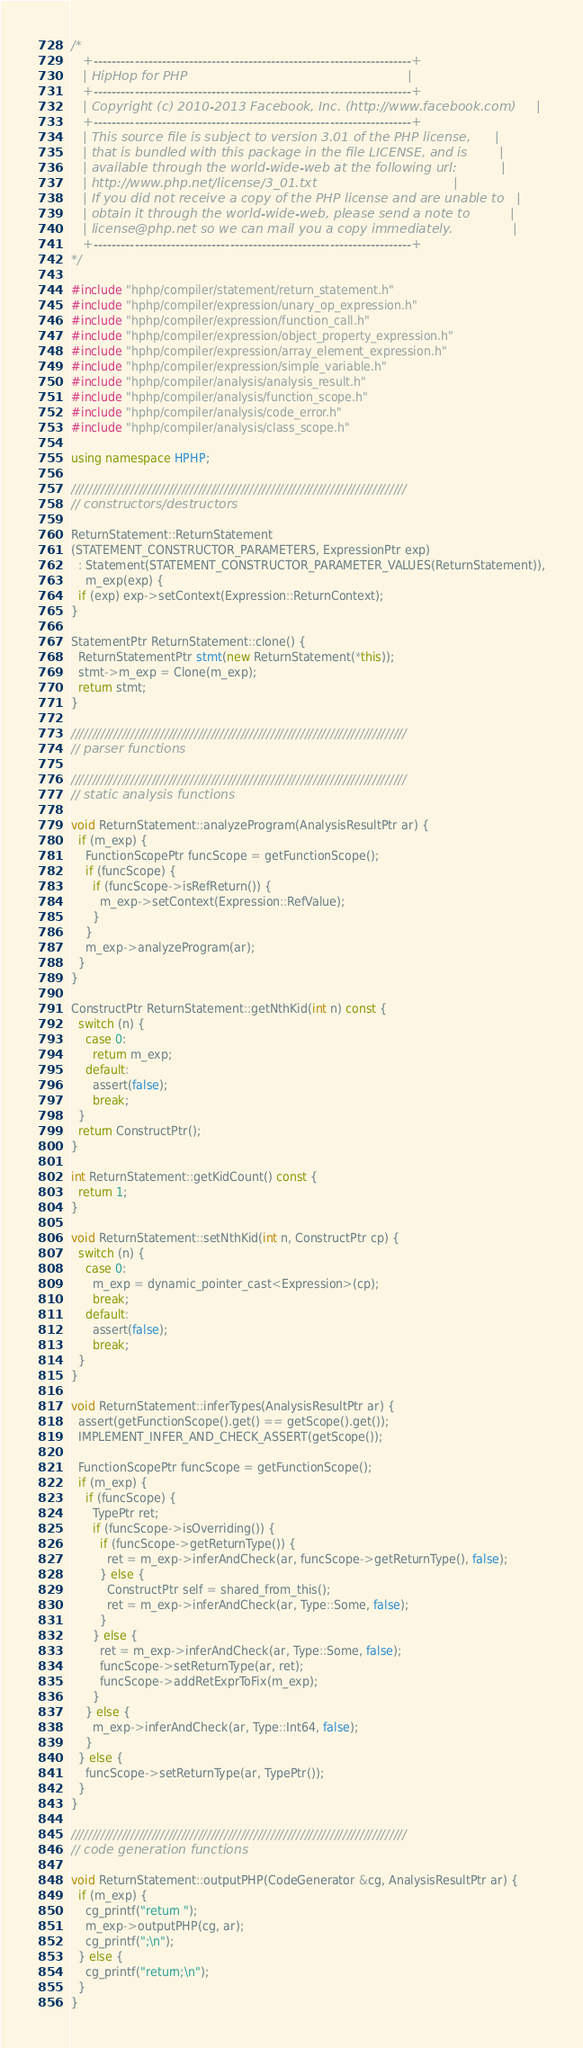<code> <loc_0><loc_0><loc_500><loc_500><_C++_>/*
   +----------------------------------------------------------------------+
   | HipHop for PHP                                                       |
   +----------------------------------------------------------------------+
   | Copyright (c) 2010-2013 Facebook, Inc. (http://www.facebook.com)     |
   +----------------------------------------------------------------------+
   | This source file is subject to version 3.01 of the PHP license,      |
   | that is bundled with this package in the file LICENSE, and is        |
   | available through the world-wide-web at the following url:           |
   | http://www.php.net/license/3_01.txt                                  |
   | If you did not receive a copy of the PHP license and are unable to   |
   | obtain it through the world-wide-web, please send a note to          |
   | license@php.net so we can mail you a copy immediately.               |
   +----------------------------------------------------------------------+
*/

#include "hphp/compiler/statement/return_statement.h"
#include "hphp/compiler/expression/unary_op_expression.h"
#include "hphp/compiler/expression/function_call.h"
#include "hphp/compiler/expression/object_property_expression.h"
#include "hphp/compiler/expression/array_element_expression.h"
#include "hphp/compiler/expression/simple_variable.h"
#include "hphp/compiler/analysis/analysis_result.h"
#include "hphp/compiler/analysis/function_scope.h"
#include "hphp/compiler/analysis/code_error.h"
#include "hphp/compiler/analysis/class_scope.h"

using namespace HPHP;

///////////////////////////////////////////////////////////////////////////////
// constructors/destructors

ReturnStatement::ReturnStatement
(STATEMENT_CONSTRUCTOR_PARAMETERS, ExpressionPtr exp)
  : Statement(STATEMENT_CONSTRUCTOR_PARAMETER_VALUES(ReturnStatement)),
    m_exp(exp) {
  if (exp) exp->setContext(Expression::ReturnContext);
}

StatementPtr ReturnStatement::clone() {
  ReturnStatementPtr stmt(new ReturnStatement(*this));
  stmt->m_exp = Clone(m_exp);
  return stmt;
}

///////////////////////////////////////////////////////////////////////////////
// parser functions

///////////////////////////////////////////////////////////////////////////////
// static analysis functions

void ReturnStatement::analyzeProgram(AnalysisResultPtr ar) {
  if (m_exp) {
    FunctionScopePtr funcScope = getFunctionScope();
    if (funcScope) {
      if (funcScope->isRefReturn()) {
        m_exp->setContext(Expression::RefValue);
      }
    }
    m_exp->analyzeProgram(ar);
  }
}

ConstructPtr ReturnStatement::getNthKid(int n) const {
  switch (n) {
    case 0:
      return m_exp;
    default:
      assert(false);
      break;
  }
  return ConstructPtr();
}

int ReturnStatement::getKidCount() const {
  return 1;
}

void ReturnStatement::setNthKid(int n, ConstructPtr cp) {
  switch (n) {
    case 0:
      m_exp = dynamic_pointer_cast<Expression>(cp);
      break;
    default:
      assert(false);
      break;
  }
}

void ReturnStatement::inferTypes(AnalysisResultPtr ar) {
  assert(getFunctionScope().get() == getScope().get());
  IMPLEMENT_INFER_AND_CHECK_ASSERT(getScope());

  FunctionScopePtr funcScope = getFunctionScope();
  if (m_exp) {
    if (funcScope) {
      TypePtr ret;
      if (funcScope->isOverriding()) {
        if (funcScope->getReturnType()) {
          ret = m_exp->inferAndCheck(ar, funcScope->getReturnType(), false);
        } else {
          ConstructPtr self = shared_from_this();
          ret = m_exp->inferAndCheck(ar, Type::Some, false);
        }
      } else {
        ret = m_exp->inferAndCheck(ar, Type::Some, false);
        funcScope->setReturnType(ar, ret);
        funcScope->addRetExprToFix(m_exp);
      }
    } else {
      m_exp->inferAndCheck(ar, Type::Int64, false);
    }
  } else {
    funcScope->setReturnType(ar, TypePtr());
  }
}

///////////////////////////////////////////////////////////////////////////////
// code generation functions

void ReturnStatement::outputPHP(CodeGenerator &cg, AnalysisResultPtr ar) {
  if (m_exp) {
    cg_printf("return ");
    m_exp->outputPHP(cg, ar);
    cg_printf(";\n");
  } else {
    cg_printf("return;\n");
  }
}
</code> 